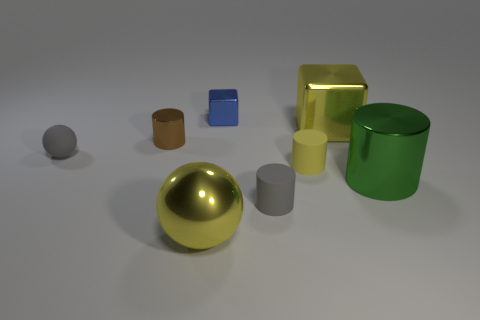How does the lighting in the image affect the appearance of the objects? The lighting in the image creates subtle shadows and highlights, which contribute to the perception of depth and the objects' three-dimensional shapes. It enhances the metallic sheen of some objects and emphasizes their reflective properties. 